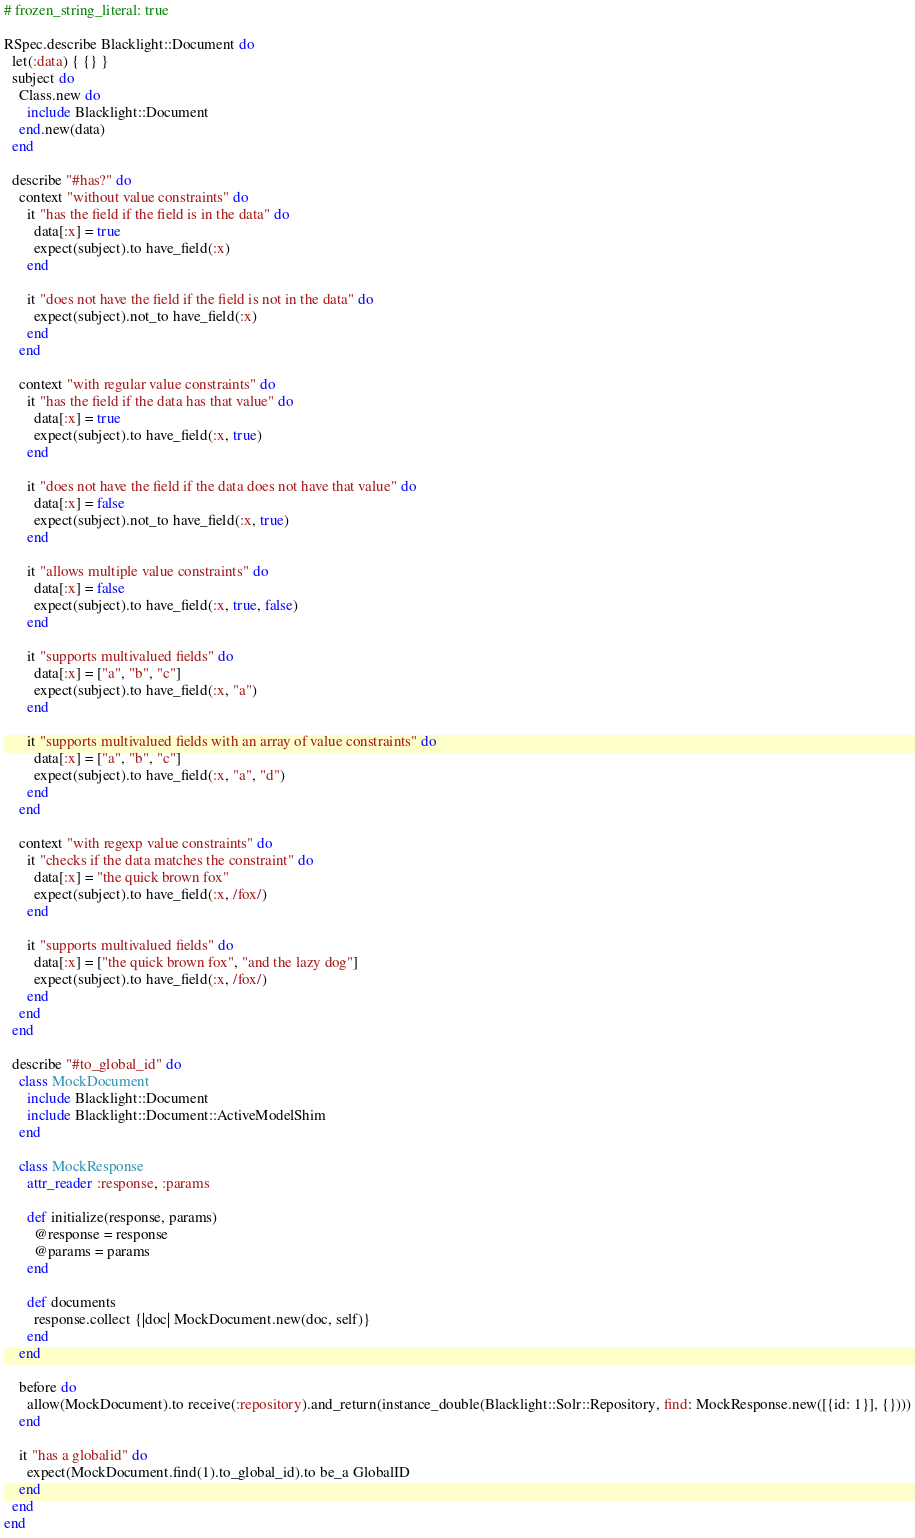<code> <loc_0><loc_0><loc_500><loc_500><_Ruby_># frozen_string_literal: true

RSpec.describe Blacklight::Document do
  let(:data) { {} }
  subject do
    Class.new do
      include Blacklight::Document
    end.new(data)
  end

  describe "#has?" do
    context "without value constraints" do
      it "has the field if the field is in the data" do
        data[:x] = true
        expect(subject).to have_field(:x)
      end
      
      it "does not have the field if the field is not in the data" do
        expect(subject).not_to have_field(:x)
      end
    end

    context "with regular value constraints" do
      it "has the field if the data has that value" do
        data[:x] = true
        expect(subject).to have_field(:x, true)
      end
      
      it "does not have the field if the data does not have that value" do
        data[:x] = false
        expect(subject).not_to have_field(:x, true)
      end

      it "allows multiple value constraints" do
        data[:x] = false
        expect(subject).to have_field(:x, true, false)
      end

      it "supports multivalued fields" do
        data[:x] = ["a", "b", "c"]
        expect(subject).to have_field(:x, "a")
      end

      it "supports multivalued fields with an array of value constraints" do
        data[:x] = ["a", "b", "c"]
        expect(subject).to have_field(:x, "a", "d")
      end
    end

    context "with regexp value constraints" do
      it "checks if the data matches the constraint" do
        data[:x] = "the quick brown fox"
        expect(subject).to have_field(:x, /fox/)
      end

      it "supports multivalued fields" do
        data[:x] = ["the quick brown fox", "and the lazy dog"]
        expect(subject).to have_field(:x, /fox/)
      end
    end
  end

  describe "#to_global_id" do
    class MockDocument
      include Blacklight::Document
      include Blacklight::Document::ActiveModelShim
    end

    class MockResponse
      attr_reader :response, :params

      def initialize(response, params)
        @response = response
        @params = params
      end

      def documents
        response.collect {|doc| MockDocument.new(doc, self)}
      end
    end

    before do
      allow(MockDocument).to receive(:repository).and_return(instance_double(Blacklight::Solr::Repository, find: MockResponse.new([{id: 1}], {})))
    end

    it "has a globalid" do
      expect(MockDocument.find(1).to_global_id).to be_a GlobalID
    end
  end
end
</code> 